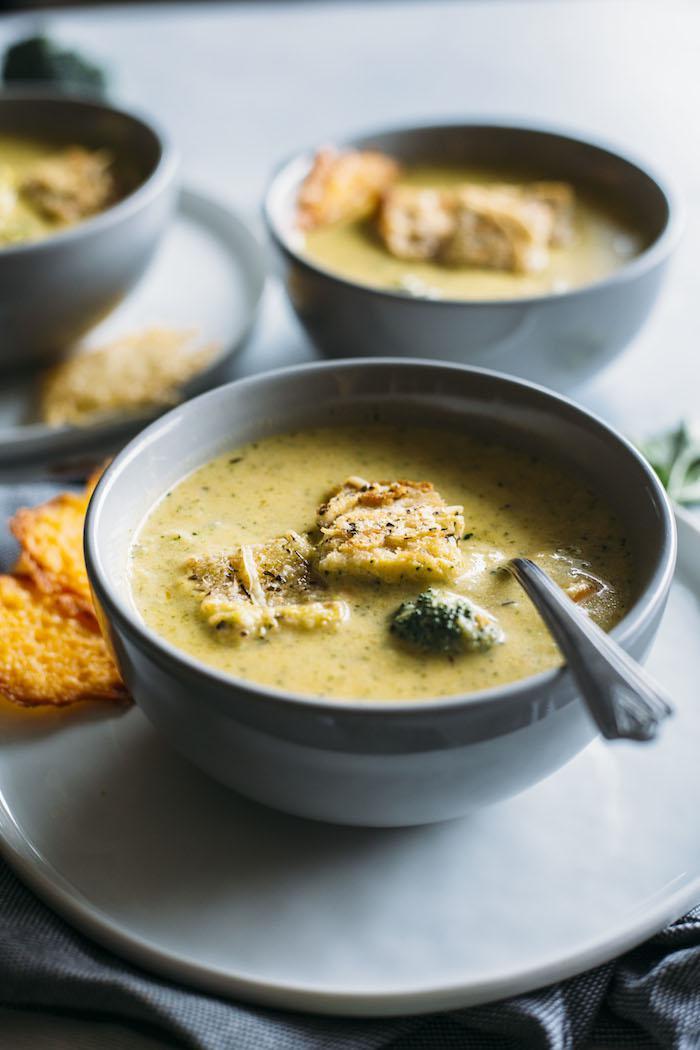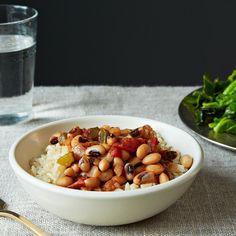The first image is the image on the left, the second image is the image on the right. Given the left and right images, does the statement "Right image shows creamy soup with colorful garnish and bread nearby." hold true? Answer yes or no. No. The first image is the image on the left, the second image is the image on the right. Considering the images on both sides, is "there is exactly one bowl with a spoon in it in the image on the right" valid? Answer yes or no. No. 